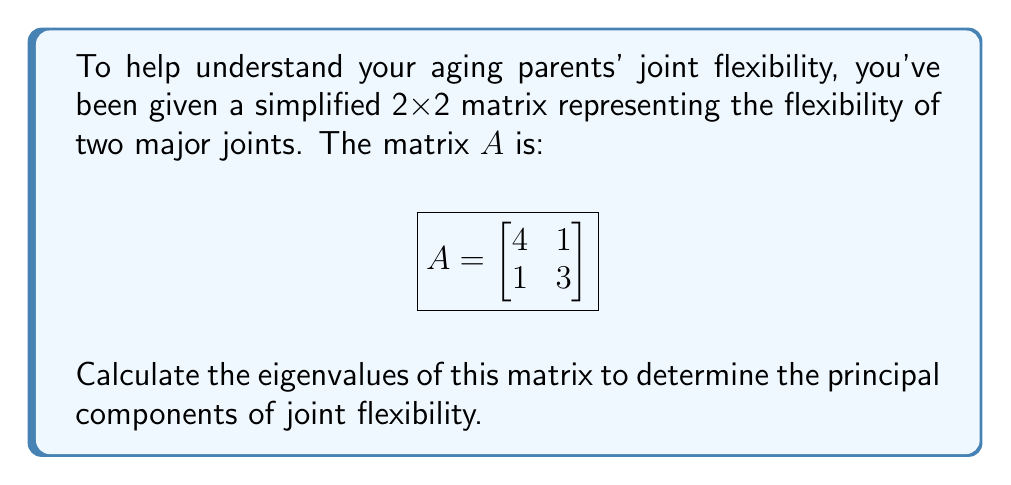Teach me how to tackle this problem. To find the eigenvalues of matrix $A$, we follow these steps:

1) The eigenvalues $\lambda$ satisfy the characteristic equation:
   $det(A - \lambda I) = 0$, where $I$ is the 2x2 identity matrix.

2) Expand the determinant:
   $$det\begin{pmatrix}
   4-\lambda & 1 \\
   1 & 3-\lambda
   \end{pmatrix} = 0$$

3) Calculate the determinant:
   $(4-\lambda)(3-\lambda) - 1 \cdot 1 = 0$

4) Expand the equation:
   $12 - 7\lambda + \lambda^2 - 1 = 0$
   $\lambda^2 - 7\lambda + 11 = 0$

5) This is a quadratic equation. We can solve it using the quadratic formula:
   $\lambda = \frac{-b \pm \sqrt{b^2 - 4ac}}{2a}$

   Where $a=1$, $b=-7$, and $c=11$

6) Substituting these values:
   $\lambda = \frac{7 \pm \sqrt{49 - 44}}{2} = \frac{7 \pm \sqrt{5}}{2}$

7) Therefore, the two eigenvalues are:
   $\lambda_1 = \frac{7 + \sqrt{5}}{2}$ and $\lambda_2 = \frac{7 - \sqrt{5}}{2}$

These eigenvalues represent the principal components of joint flexibility in your aging parents' model.
Answer: $\lambda_1 = \frac{7 + \sqrt{5}}{2}$, $\lambda_2 = \frac{7 - \sqrt{5}}{2}$ 